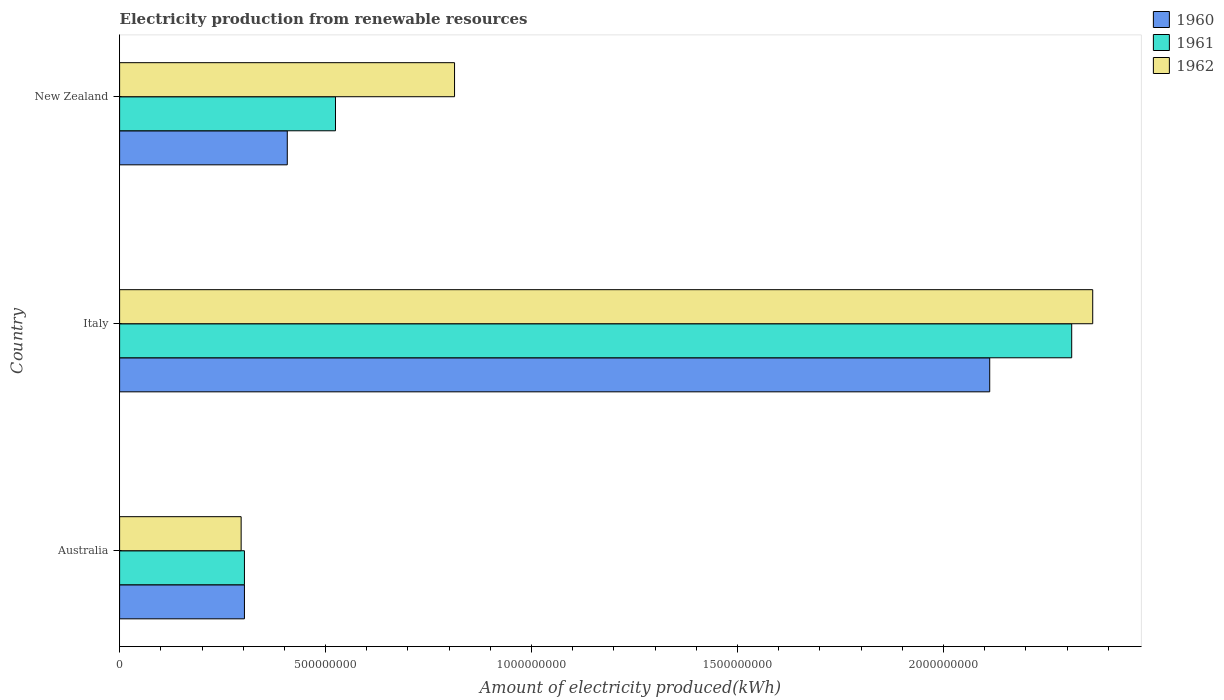How many different coloured bars are there?
Ensure brevity in your answer.  3. Are the number of bars on each tick of the Y-axis equal?
Offer a terse response. Yes. How many bars are there on the 3rd tick from the top?
Keep it short and to the point. 3. What is the amount of electricity produced in 1960 in Australia?
Your response must be concise. 3.03e+08. Across all countries, what is the maximum amount of electricity produced in 1960?
Your answer should be compact. 2.11e+09. Across all countries, what is the minimum amount of electricity produced in 1962?
Keep it short and to the point. 2.95e+08. What is the total amount of electricity produced in 1961 in the graph?
Keep it short and to the point. 3.14e+09. What is the difference between the amount of electricity produced in 1961 in Italy and that in New Zealand?
Your answer should be compact. 1.79e+09. What is the difference between the amount of electricity produced in 1962 in New Zealand and the amount of electricity produced in 1961 in Italy?
Provide a short and direct response. -1.50e+09. What is the average amount of electricity produced in 1960 per country?
Make the answer very short. 9.41e+08. What is the difference between the amount of electricity produced in 1962 and amount of electricity produced in 1961 in Australia?
Offer a very short reply. -8.00e+06. What is the ratio of the amount of electricity produced in 1960 in Australia to that in Italy?
Give a very brief answer. 0.14. What is the difference between the highest and the second highest amount of electricity produced in 1962?
Make the answer very short. 1.55e+09. What is the difference between the highest and the lowest amount of electricity produced in 1961?
Your response must be concise. 2.01e+09. In how many countries, is the amount of electricity produced in 1960 greater than the average amount of electricity produced in 1960 taken over all countries?
Provide a succinct answer. 1. Is it the case that in every country, the sum of the amount of electricity produced in 1962 and amount of electricity produced in 1961 is greater than the amount of electricity produced in 1960?
Keep it short and to the point. Yes. How many bars are there?
Provide a short and direct response. 9. Are the values on the major ticks of X-axis written in scientific E-notation?
Provide a succinct answer. No. How many legend labels are there?
Provide a short and direct response. 3. How are the legend labels stacked?
Your answer should be very brief. Vertical. What is the title of the graph?
Your answer should be compact. Electricity production from renewable resources. What is the label or title of the X-axis?
Ensure brevity in your answer.  Amount of electricity produced(kWh). What is the Amount of electricity produced(kWh) in 1960 in Australia?
Ensure brevity in your answer.  3.03e+08. What is the Amount of electricity produced(kWh) in 1961 in Australia?
Your answer should be very brief. 3.03e+08. What is the Amount of electricity produced(kWh) in 1962 in Australia?
Your answer should be compact. 2.95e+08. What is the Amount of electricity produced(kWh) of 1960 in Italy?
Provide a short and direct response. 2.11e+09. What is the Amount of electricity produced(kWh) of 1961 in Italy?
Ensure brevity in your answer.  2.31e+09. What is the Amount of electricity produced(kWh) in 1962 in Italy?
Make the answer very short. 2.36e+09. What is the Amount of electricity produced(kWh) of 1960 in New Zealand?
Keep it short and to the point. 4.07e+08. What is the Amount of electricity produced(kWh) in 1961 in New Zealand?
Offer a terse response. 5.24e+08. What is the Amount of electricity produced(kWh) of 1962 in New Zealand?
Provide a succinct answer. 8.13e+08. Across all countries, what is the maximum Amount of electricity produced(kWh) in 1960?
Offer a very short reply. 2.11e+09. Across all countries, what is the maximum Amount of electricity produced(kWh) of 1961?
Your answer should be compact. 2.31e+09. Across all countries, what is the maximum Amount of electricity produced(kWh) in 1962?
Make the answer very short. 2.36e+09. Across all countries, what is the minimum Amount of electricity produced(kWh) in 1960?
Offer a terse response. 3.03e+08. Across all countries, what is the minimum Amount of electricity produced(kWh) of 1961?
Provide a short and direct response. 3.03e+08. Across all countries, what is the minimum Amount of electricity produced(kWh) in 1962?
Provide a short and direct response. 2.95e+08. What is the total Amount of electricity produced(kWh) in 1960 in the graph?
Keep it short and to the point. 2.82e+09. What is the total Amount of electricity produced(kWh) of 1961 in the graph?
Provide a short and direct response. 3.14e+09. What is the total Amount of electricity produced(kWh) in 1962 in the graph?
Offer a very short reply. 3.47e+09. What is the difference between the Amount of electricity produced(kWh) of 1960 in Australia and that in Italy?
Provide a succinct answer. -1.81e+09. What is the difference between the Amount of electricity produced(kWh) in 1961 in Australia and that in Italy?
Make the answer very short. -2.01e+09. What is the difference between the Amount of electricity produced(kWh) of 1962 in Australia and that in Italy?
Your answer should be very brief. -2.07e+09. What is the difference between the Amount of electricity produced(kWh) in 1960 in Australia and that in New Zealand?
Provide a short and direct response. -1.04e+08. What is the difference between the Amount of electricity produced(kWh) of 1961 in Australia and that in New Zealand?
Your response must be concise. -2.21e+08. What is the difference between the Amount of electricity produced(kWh) of 1962 in Australia and that in New Zealand?
Keep it short and to the point. -5.18e+08. What is the difference between the Amount of electricity produced(kWh) of 1960 in Italy and that in New Zealand?
Your answer should be very brief. 1.70e+09. What is the difference between the Amount of electricity produced(kWh) of 1961 in Italy and that in New Zealand?
Your response must be concise. 1.79e+09. What is the difference between the Amount of electricity produced(kWh) in 1962 in Italy and that in New Zealand?
Your response must be concise. 1.55e+09. What is the difference between the Amount of electricity produced(kWh) of 1960 in Australia and the Amount of electricity produced(kWh) of 1961 in Italy?
Offer a very short reply. -2.01e+09. What is the difference between the Amount of electricity produced(kWh) in 1960 in Australia and the Amount of electricity produced(kWh) in 1962 in Italy?
Provide a short and direct response. -2.06e+09. What is the difference between the Amount of electricity produced(kWh) in 1961 in Australia and the Amount of electricity produced(kWh) in 1962 in Italy?
Offer a terse response. -2.06e+09. What is the difference between the Amount of electricity produced(kWh) of 1960 in Australia and the Amount of electricity produced(kWh) of 1961 in New Zealand?
Your response must be concise. -2.21e+08. What is the difference between the Amount of electricity produced(kWh) in 1960 in Australia and the Amount of electricity produced(kWh) in 1962 in New Zealand?
Your answer should be very brief. -5.10e+08. What is the difference between the Amount of electricity produced(kWh) of 1961 in Australia and the Amount of electricity produced(kWh) of 1962 in New Zealand?
Provide a succinct answer. -5.10e+08. What is the difference between the Amount of electricity produced(kWh) in 1960 in Italy and the Amount of electricity produced(kWh) in 1961 in New Zealand?
Give a very brief answer. 1.59e+09. What is the difference between the Amount of electricity produced(kWh) of 1960 in Italy and the Amount of electricity produced(kWh) of 1962 in New Zealand?
Offer a very short reply. 1.30e+09. What is the difference between the Amount of electricity produced(kWh) in 1961 in Italy and the Amount of electricity produced(kWh) in 1962 in New Zealand?
Your answer should be compact. 1.50e+09. What is the average Amount of electricity produced(kWh) in 1960 per country?
Offer a terse response. 9.41e+08. What is the average Amount of electricity produced(kWh) in 1961 per country?
Give a very brief answer. 1.05e+09. What is the average Amount of electricity produced(kWh) of 1962 per country?
Offer a terse response. 1.16e+09. What is the difference between the Amount of electricity produced(kWh) of 1961 and Amount of electricity produced(kWh) of 1962 in Australia?
Your response must be concise. 8.00e+06. What is the difference between the Amount of electricity produced(kWh) in 1960 and Amount of electricity produced(kWh) in 1961 in Italy?
Make the answer very short. -1.99e+08. What is the difference between the Amount of electricity produced(kWh) in 1960 and Amount of electricity produced(kWh) in 1962 in Italy?
Give a very brief answer. -2.50e+08. What is the difference between the Amount of electricity produced(kWh) of 1961 and Amount of electricity produced(kWh) of 1962 in Italy?
Keep it short and to the point. -5.10e+07. What is the difference between the Amount of electricity produced(kWh) in 1960 and Amount of electricity produced(kWh) in 1961 in New Zealand?
Provide a succinct answer. -1.17e+08. What is the difference between the Amount of electricity produced(kWh) in 1960 and Amount of electricity produced(kWh) in 1962 in New Zealand?
Your answer should be very brief. -4.06e+08. What is the difference between the Amount of electricity produced(kWh) of 1961 and Amount of electricity produced(kWh) of 1962 in New Zealand?
Offer a very short reply. -2.89e+08. What is the ratio of the Amount of electricity produced(kWh) in 1960 in Australia to that in Italy?
Provide a short and direct response. 0.14. What is the ratio of the Amount of electricity produced(kWh) in 1961 in Australia to that in Italy?
Ensure brevity in your answer.  0.13. What is the ratio of the Amount of electricity produced(kWh) in 1962 in Australia to that in Italy?
Ensure brevity in your answer.  0.12. What is the ratio of the Amount of electricity produced(kWh) of 1960 in Australia to that in New Zealand?
Offer a very short reply. 0.74. What is the ratio of the Amount of electricity produced(kWh) of 1961 in Australia to that in New Zealand?
Your answer should be compact. 0.58. What is the ratio of the Amount of electricity produced(kWh) of 1962 in Australia to that in New Zealand?
Give a very brief answer. 0.36. What is the ratio of the Amount of electricity produced(kWh) in 1960 in Italy to that in New Zealand?
Offer a very short reply. 5.19. What is the ratio of the Amount of electricity produced(kWh) in 1961 in Italy to that in New Zealand?
Keep it short and to the point. 4.41. What is the ratio of the Amount of electricity produced(kWh) in 1962 in Italy to that in New Zealand?
Keep it short and to the point. 2.91. What is the difference between the highest and the second highest Amount of electricity produced(kWh) in 1960?
Ensure brevity in your answer.  1.70e+09. What is the difference between the highest and the second highest Amount of electricity produced(kWh) in 1961?
Offer a terse response. 1.79e+09. What is the difference between the highest and the second highest Amount of electricity produced(kWh) in 1962?
Offer a terse response. 1.55e+09. What is the difference between the highest and the lowest Amount of electricity produced(kWh) in 1960?
Keep it short and to the point. 1.81e+09. What is the difference between the highest and the lowest Amount of electricity produced(kWh) of 1961?
Offer a very short reply. 2.01e+09. What is the difference between the highest and the lowest Amount of electricity produced(kWh) in 1962?
Your response must be concise. 2.07e+09. 